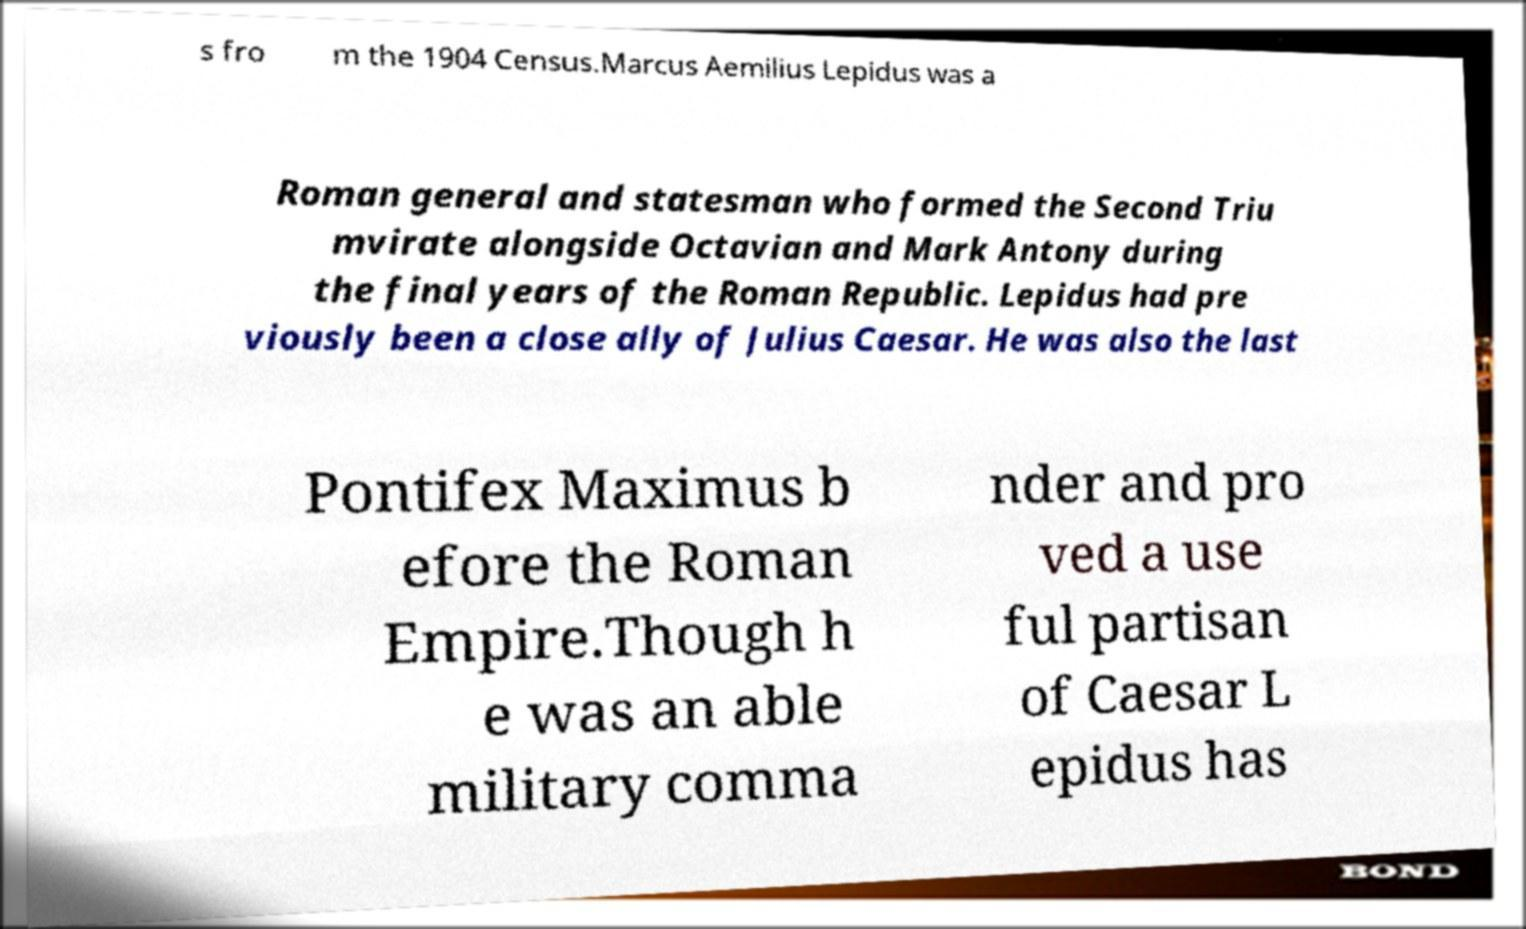Please read and relay the text visible in this image. What does it say? s fro m the 1904 Census.Marcus Aemilius Lepidus was a Roman general and statesman who formed the Second Triu mvirate alongside Octavian and Mark Antony during the final years of the Roman Republic. Lepidus had pre viously been a close ally of Julius Caesar. He was also the last Pontifex Maximus b efore the Roman Empire.Though h e was an able military comma nder and pro ved a use ful partisan of Caesar L epidus has 